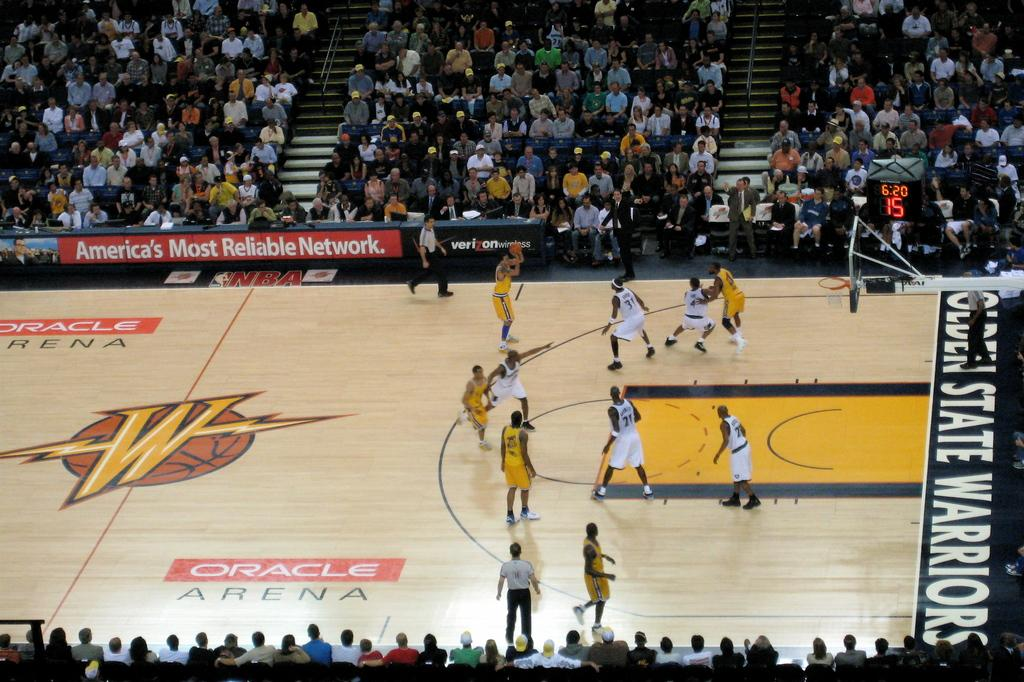Provide a one-sentence caption for the provided image. The Golden States Warriors are playing basketball aganst another team. 